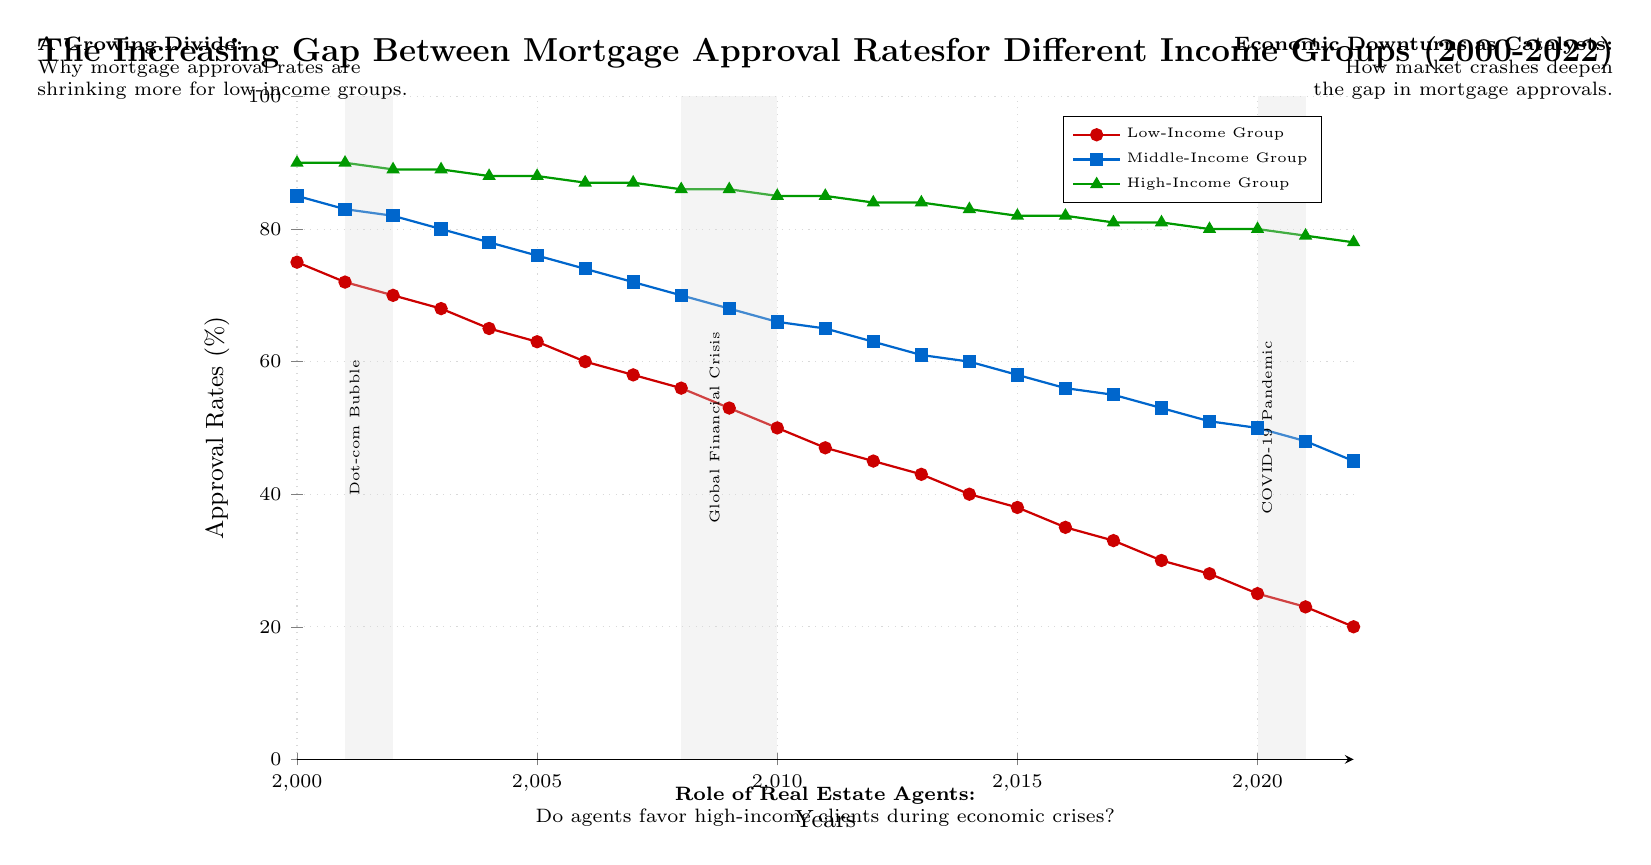What was the mortgage approval rate for the low-income group in 2000? The diagram shows the approval rate for the low-income group at 75% in the year 2000. This can be found at the point where the low-income line intersects the y-axis at 2000.
Answer: 75% Which income group had the highest mortgage approval rate in 2022? According to the diagram in 2022, the high-income group had the highest approval rate at 78%. This is determined by comparing the approval rates of all groups at the year 2022.
Answer: 78% What trend is observed for the low-income group from 2000 to 2022? The approval rate for the low-income group shows a downward trend from 75% in 2000 to 20% in 2022. This downward slope indicates a consistent decline over the years, demonstrating the widening gap between income groups.
Answer: Downward During which time period did the first economic downturn occur? The first economic downturn is noted on the diagram as occurring from 2001 to 2002, identified by the shaded region labeled "Dot-com Bubble". The shading starts in 2001 and ends in 2002.
Answer: 2001-2002 How much did the middle-income group's approval rate decrease from 2020 to 2022? The middle-income group had an approval rate of 50% in 2020 and decreased to 45% in 2022, resulting in a decrease of 5%. This is calculated by subtracting the 2022 value from the 2020 value.
Answer: 5% How does the approval rate for high-income groups compare to low-income groups in 2010? In 2010, the high-income group's approval rate was 85%, while the low-income group's was 50%. This comparison shows that high-income groups had a 35 percentage point advantage over low-income groups in that year.
Answer: 35 percentage points What is the visible effect of the global financial crisis on the low-income approval rates? The diagram shows a dramatic drop in low-income mortgage approval rates during the global financial crisis (2008-2010), where rates fall from 58% in 2007 to 53% in 2009, indicating a significant negative impact during this downturn.
Answer: Significant drop Did the approval rate for the high-income group decline during the COVID-19 pandemic? Yes, the approval rate for the high-income group did decline during the COVID-19 pandemic, dropping from 80% in 2019 to 79% in 2021. This indicates they also faced a reduction in approval rates during this period.
Answer: Yes Which income group consistently had the highest approval rates throughout the given years? Throughout the years presented in the diagram, the high-income group consistently had the highest approval rates, as indicated by their line remaining above the other two groups in all plotted years.
Answer: High-Income Group 